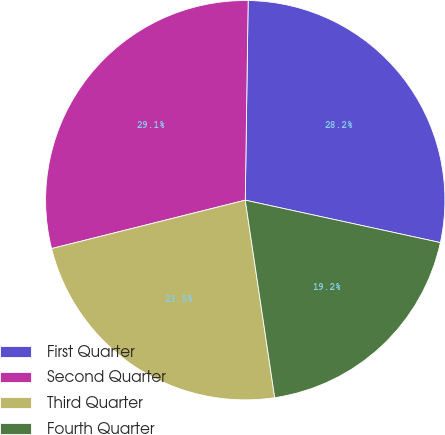Convert chart to OTSL. <chart><loc_0><loc_0><loc_500><loc_500><pie_chart><fcel>First Quarter<fcel>Second Quarter<fcel>Third Quarter<fcel>Fourth Quarter<nl><fcel>28.18%<fcel>29.13%<fcel>23.46%<fcel>19.24%<nl></chart> 